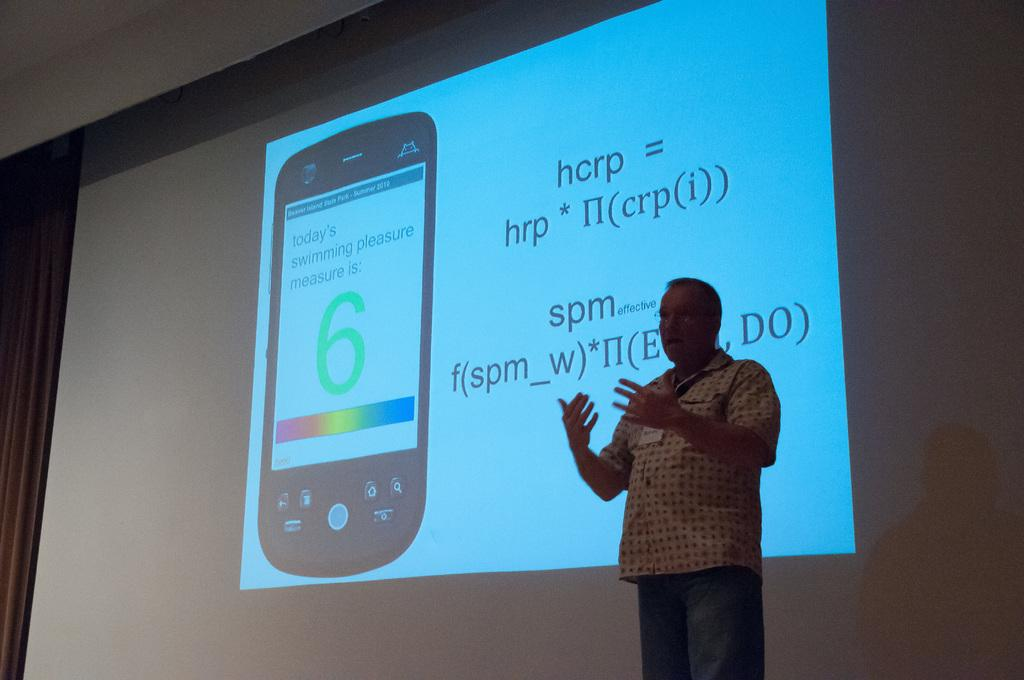<image>
Describe the image concisely. A man is giving a presentation in front of a projector screen with an equation for hcrp. 